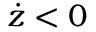<formula> <loc_0><loc_0><loc_500><loc_500>\dot { z } < 0</formula> 